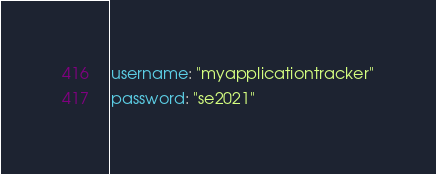<code> <loc_0><loc_0><loc_500><loc_500><_YAML_>username: "myapplicationtracker"
password: "se2021"</code> 